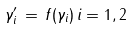<formula> <loc_0><loc_0><loc_500><loc_500>\gamma _ { i } ^ { \prime } \, = \, f ( \gamma _ { i } ) \, i = 1 , 2</formula> 